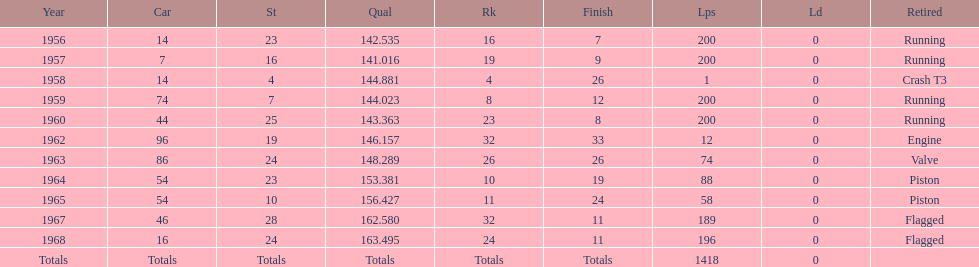What was its best starting position? 4. 